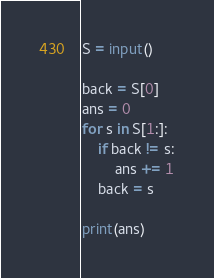<code> <loc_0><loc_0><loc_500><loc_500><_Python_>S = input()

back = S[0]
ans = 0
for s in S[1:]:
    if back != s:
        ans += 1
    back = s
    
print(ans)</code> 